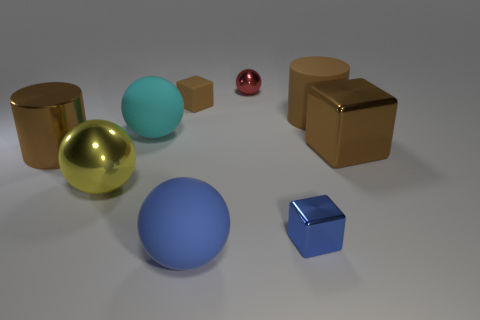Can you discuss the composition and balance of objects in the image? The composition features a balance of geometric shapes and colors. The spheres, cubes, and one cylinder are arranged in such a way that each shape and color has space to be observed, creating an harmonious visual balance without overcrowding any single area. 